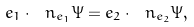Convert formula to latex. <formula><loc_0><loc_0><loc_500><loc_500>e _ { 1 } \cdot \ n _ { e _ { 1 } } \Psi = e _ { 2 } \cdot \ n _ { e _ { 2 } } \Psi ,</formula> 